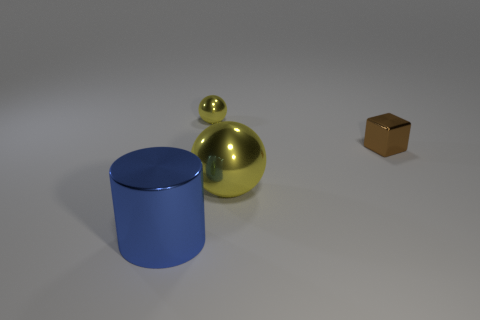Add 3 big metallic cylinders. How many objects exist? 7 Subtract all blue cubes. Subtract all red balls. How many cubes are left? 1 Subtract all big blue objects. Subtract all big blue metallic objects. How many objects are left? 2 Add 4 big yellow balls. How many big yellow balls are left? 5 Add 1 yellow metallic things. How many yellow metallic things exist? 3 Subtract 0 cyan cylinders. How many objects are left? 4 